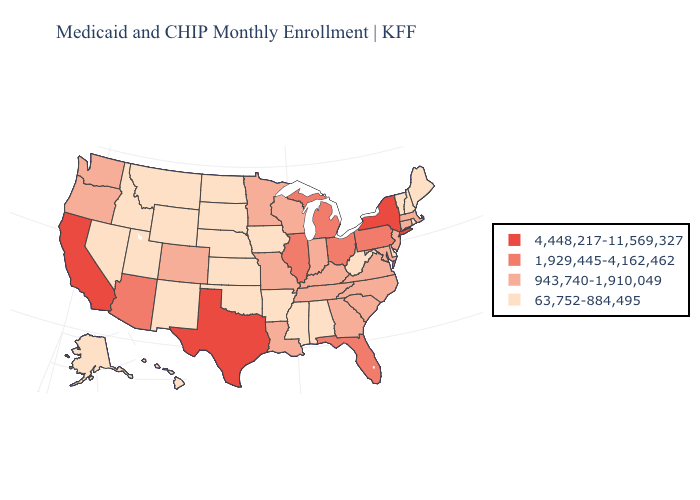What is the lowest value in the USA?
Give a very brief answer. 63,752-884,495. What is the value of Georgia?
Answer briefly. 943,740-1,910,049. What is the lowest value in the Northeast?
Short answer required. 63,752-884,495. Among the states that border Wisconsin , does Iowa have the highest value?
Keep it brief. No. How many symbols are there in the legend?
Quick response, please. 4. What is the value of Arizona?
Give a very brief answer. 1,929,445-4,162,462. Which states hav the highest value in the MidWest?
Be succinct. Illinois, Michigan, Ohio. What is the highest value in the Northeast ?
Give a very brief answer. 4,448,217-11,569,327. Name the states that have a value in the range 63,752-884,495?
Keep it brief. Alabama, Alaska, Arkansas, Delaware, Hawaii, Idaho, Iowa, Kansas, Maine, Mississippi, Montana, Nebraska, Nevada, New Hampshire, New Mexico, North Dakota, Oklahoma, Rhode Island, South Dakota, Utah, Vermont, West Virginia, Wyoming. What is the lowest value in states that border Georgia?
Be succinct. 63,752-884,495. What is the value of Georgia?
Be succinct. 943,740-1,910,049. What is the value of Hawaii?
Keep it brief. 63,752-884,495. What is the highest value in states that border Alabama?
Quick response, please. 1,929,445-4,162,462. Which states have the highest value in the USA?
Be succinct. California, New York, Texas. Does the first symbol in the legend represent the smallest category?
Be succinct. No. 